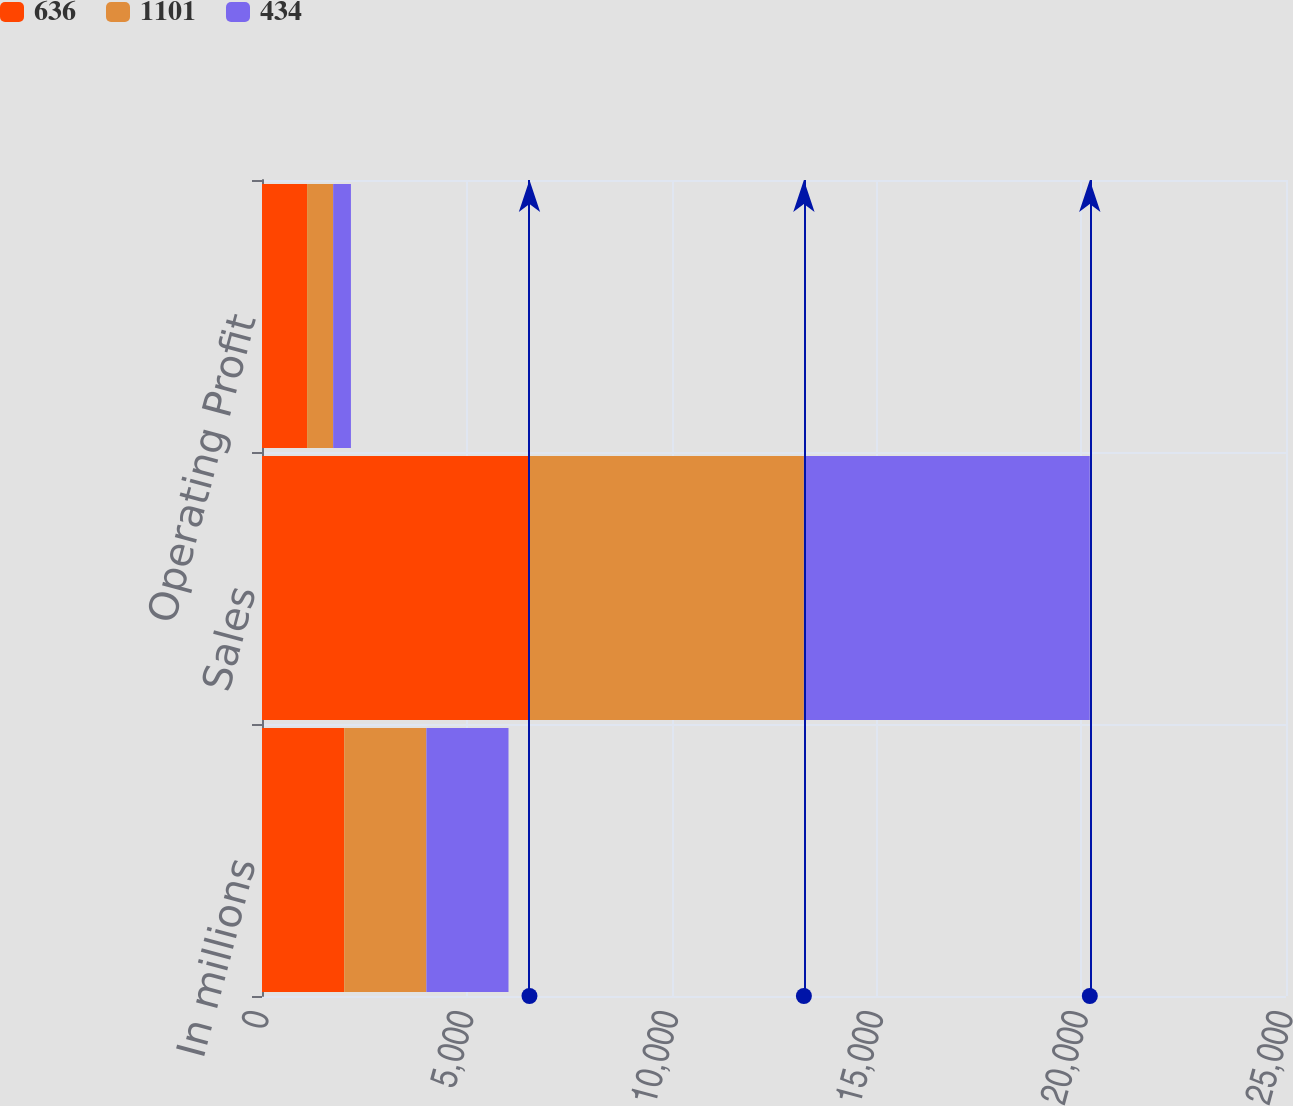Convert chart to OTSL. <chart><loc_0><loc_0><loc_500><loc_500><stacked_bar_chart><ecel><fcel>In millions<fcel>Sales<fcel>Operating Profit<nl><fcel>636<fcel>2007<fcel>6530<fcel>1101<nl><fcel>1101<fcel>2006<fcel>6700<fcel>636<nl><fcel>434<fcel>2005<fcel>6980<fcel>434<nl></chart> 